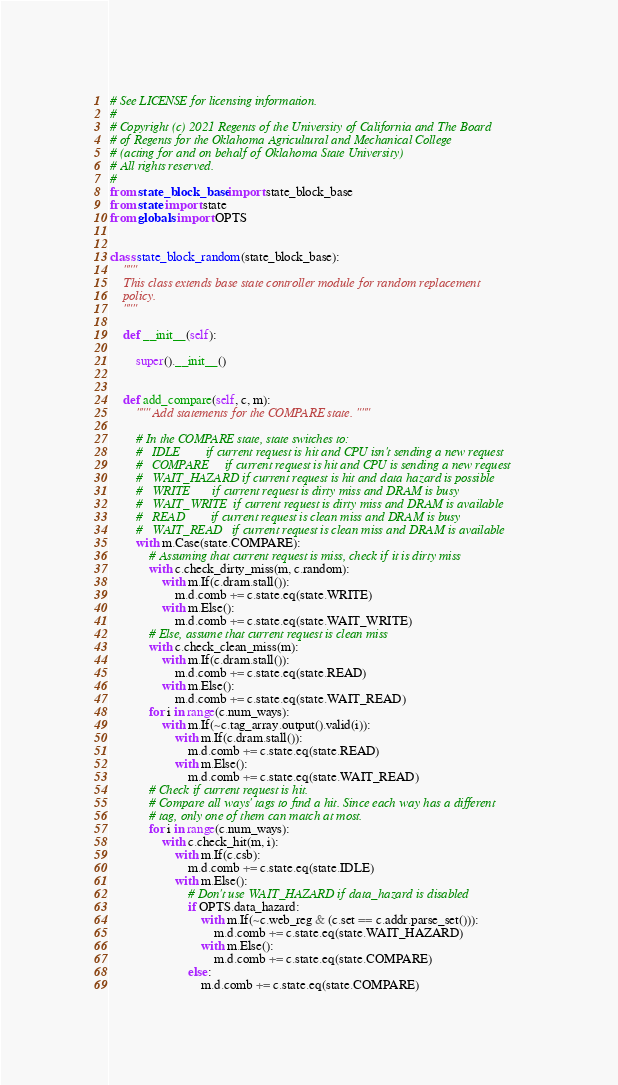<code> <loc_0><loc_0><loc_500><loc_500><_Python_># See LICENSE for licensing information.
#
# Copyright (c) 2021 Regents of the University of California and The Board
# of Regents for the Oklahoma Agricultural and Mechanical College
# (acting for and on behalf of Oklahoma State University)
# All rights reserved.
#
from state_block_base import state_block_base
from state import state
from globals import OPTS


class state_block_random(state_block_base):
    """
    This class extends base state controller module for random replacement
    policy.
    """

    def __init__(self):

        super().__init__()


    def add_compare(self, c, m):
        """ Add statements for the COMPARE state. """

        # In the COMPARE state, state switches to:
        #   IDLE        if current request is hit and CPU isn't sending a new request
        #   COMPARE     if current request is hit and CPU is sending a new request
        #   WAIT_HAZARD if current request is hit and data hazard is possible
        #   WRITE       if current request is dirty miss and DRAM is busy
        #   WAIT_WRITE  if current request is dirty miss and DRAM is available
        #   READ        if current request is clean miss and DRAM is busy
        #   WAIT_READ   if current request is clean miss and DRAM is available
        with m.Case(state.COMPARE):
            # Assuming that current request is miss, check if it is dirty miss
            with c.check_dirty_miss(m, c.random):
                with m.If(c.dram.stall()):
                    m.d.comb += c.state.eq(state.WRITE)
                with m.Else():
                    m.d.comb += c.state.eq(state.WAIT_WRITE)
            # Else, assume that current request is clean miss
            with c.check_clean_miss(m):
                with m.If(c.dram.stall()):
                    m.d.comb += c.state.eq(state.READ)
                with m.Else():
                    m.d.comb += c.state.eq(state.WAIT_READ)
            for i in range(c.num_ways):
                with m.If(~c.tag_array.output().valid(i)):
                    with m.If(c.dram.stall()):
                        m.d.comb += c.state.eq(state.READ)
                    with m.Else():
                        m.d.comb += c.state.eq(state.WAIT_READ)
            # Check if current request is hit.
            # Compare all ways' tags to find a hit. Since each way has a different
            # tag, only one of them can match at most.
            for i in range(c.num_ways):
                with c.check_hit(m, i):
                    with m.If(c.csb):
                        m.d.comb += c.state.eq(state.IDLE)
                    with m.Else():
                        # Don't use WAIT_HAZARD if data_hazard is disabled
                        if OPTS.data_hazard:
                            with m.If(~c.web_reg & (c.set == c.addr.parse_set())):
                                m.d.comb += c.state.eq(state.WAIT_HAZARD)
                            with m.Else():
                                m.d.comb += c.state.eq(state.COMPARE)
                        else:
                            m.d.comb += c.state.eq(state.COMPARE)</code> 